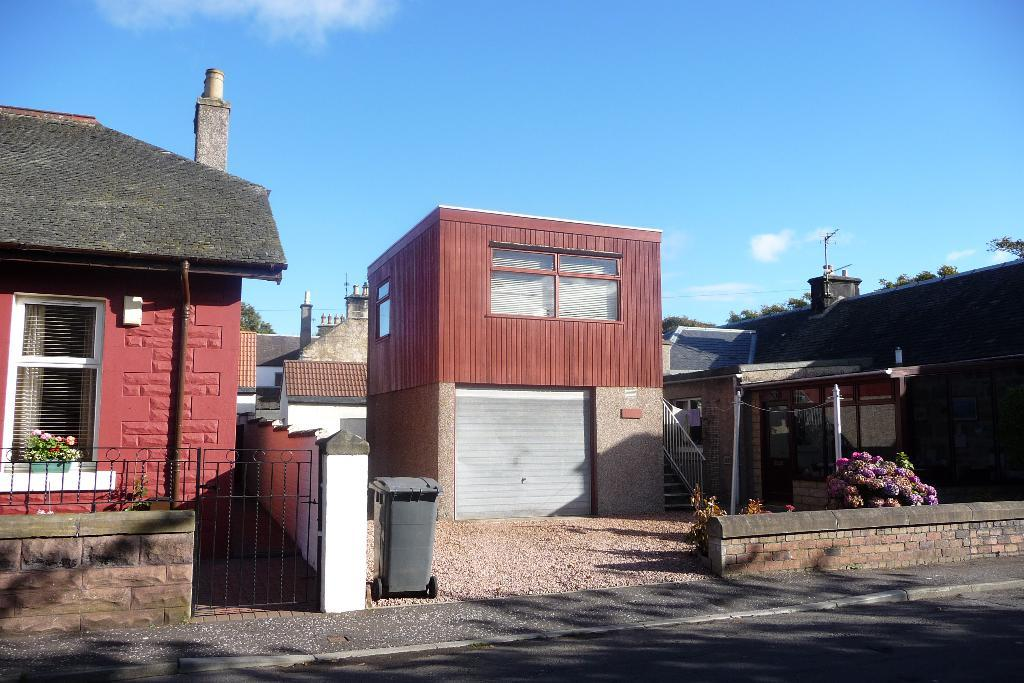What type of structures can be seen in the image? There are buildings in the image. What type of vegetation is present in the image? There are houseplants, bushes, and trees visible in the image. What architectural features can be seen in the image? Iron grills, a staircase, railing, poles, chimneys, and antennas are visible in the image. What is the purpose of the trash bin in the image? The trash bin is present in the image for waste disposal. What can be seen in the sky in the image? The sky is visible in the image, and clouds are present. What type of nut is being used to hold the lamp in the image? There is no lamp or nut present in the image. How does the stretch of the buildings affect the overall composition of the image? The image does not depict a stretch of buildings; it shows individual buildings with various architectural features. 